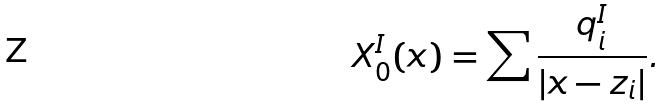Convert formula to latex. <formula><loc_0><loc_0><loc_500><loc_500>X _ { 0 } ^ { I } ( x ) = \sum \frac { q _ { i } ^ { I } } { | x - z _ { i } | } .</formula> 